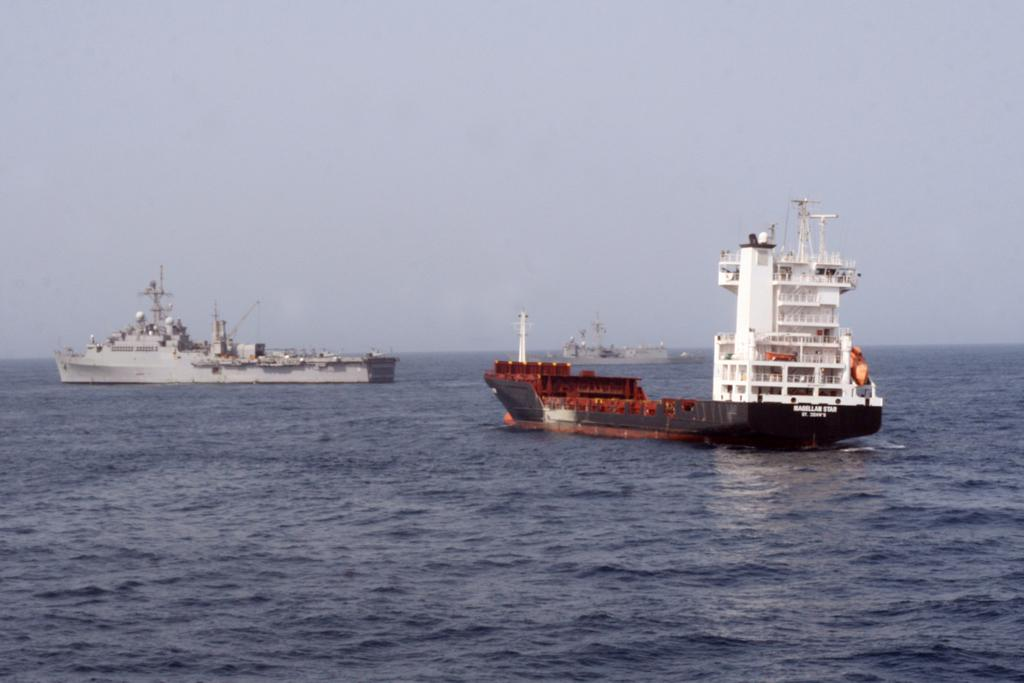What is the main subject of the image? The main subject of the image is ships. Where are the ships located? The ships are on the water. What else can be seen in the image besides the ships? The sky is visible at the top of the image. How many clovers can be seen growing near the ships in the image? There are no clovers present in the image; it features ships on the water with the sky visible at the top. 